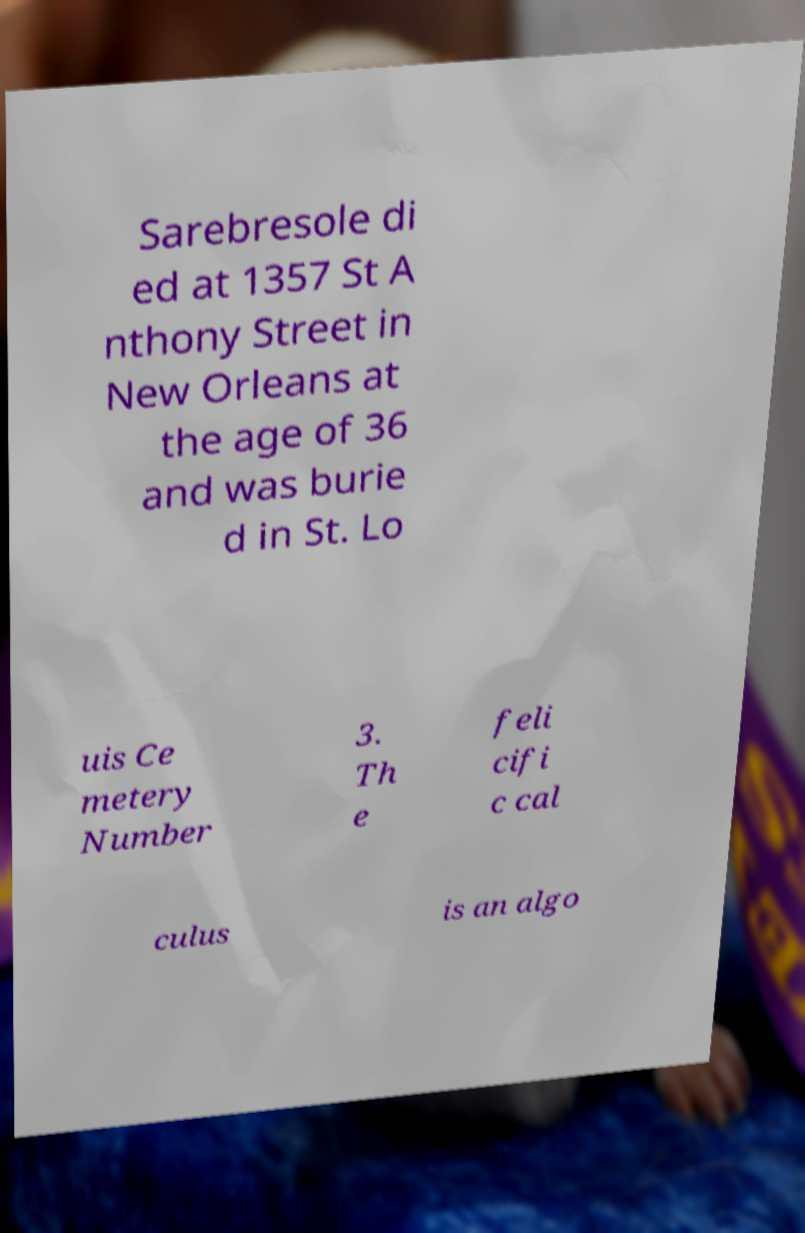Could you extract and type out the text from this image? Sarebresole di ed at 1357 St A nthony Street in New Orleans at the age of 36 and was burie d in St. Lo uis Ce metery Number 3. Th e feli cifi c cal culus is an algo 